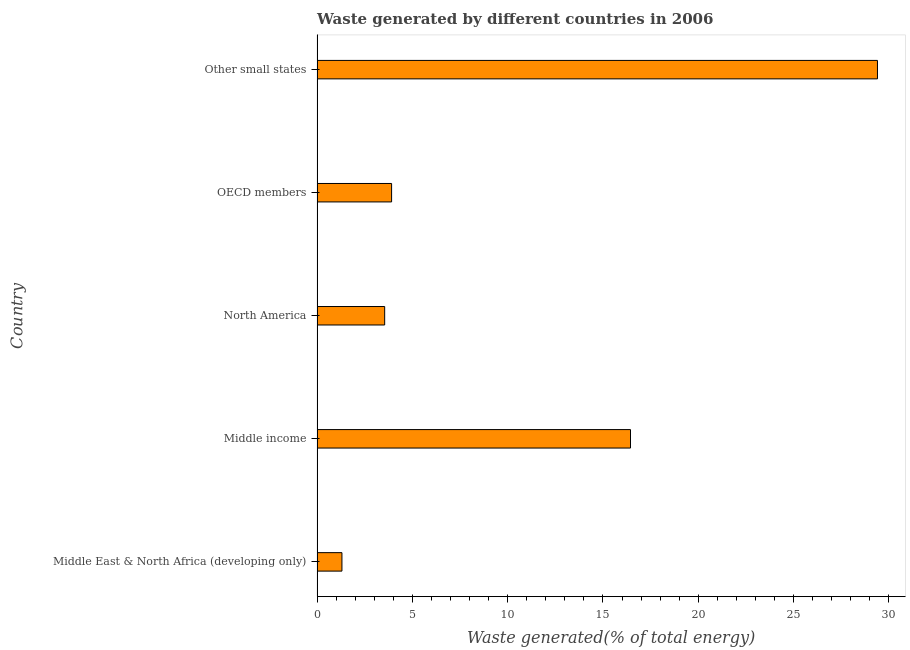What is the title of the graph?
Provide a short and direct response. Waste generated by different countries in 2006. What is the label or title of the X-axis?
Keep it short and to the point. Waste generated(% of total energy). What is the amount of waste generated in Middle income?
Your answer should be very brief. 16.44. Across all countries, what is the maximum amount of waste generated?
Your answer should be compact. 29.4. Across all countries, what is the minimum amount of waste generated?
Your answer should be compact. 1.31. In which country was the amount of waste generated maximum?
Make the answer very short. Other small states. In which country was the amount of waste generated minimum?
Give a very brief answer. Middle East & North Africa (developing only). What is the sum of the amount of waste generated?
Provide a short and direct response. 54.61. What is the difference between the amount of waste generated in Middle East & North Africa (developing only) and North America?
Provide a short and direct response. -2.24. What is the average amount of waste generated per country?
Your answer should be compact. 10.92. What is the median amount of waste generated?
Give a very brief answer. 3.91. What is the ratio of the amount of waste generated in Middle East & North Africa (developing only) to that in Other small states?
Give a very brief answer. 0.04. Is the difference between the amount of waste generated in Middle East & North Africa (developing only) and OECD members greater than the difference between any two countries?
Give a very brief answer. No. What is the difference between the highest and the second highest amount of waste generated?
Give a very brief answer. 12.96. Is the sum of the amount of waste generated in North America and Other small states greater than the maximum amount of waste generated across all countries?
Provide a succinct answer. Yes. What is the difference between the highest and the lowest amount of waste generated?
Offer a terse response. 28.1. How many bars are there?
Your answer should be compact. 5. What is the difference between two consecutive major ticks on the X-axis?
Provide a short and direct response. 5. Are the values on the major ticks of X-axis written in scientific E-notation?
Your response must be concise. No. What is the Waste generated(% of total energy) of Middle East & North Africa (developing only)?
Your response must be concise. 1.31. What is the Waste generated(% of total energy) of Middle income?
Give a very brief answer. 16.44. What is the Waste generated(% of total energy) of North America?
Keep it short and to the point. 3.55. What is the Waste generated(% of total energy) in OECD members?
Make the answer very short. 3.91. What is the Waste generated(% of total energy) in Other small states?
Your answer should be compact. 29.4. What is the difference between the Waste generated(% of total energy) in Middle East & North Africa (developing only) and Middle income?
Offer a terse response. -15.14. What is the difference between the Waste generated(% of total energy) in Middle East & North Africa (developing only) and North America?
Offer a very short reply. -2.24. What is the difference between the Waste generated(% of total energy) in Middle East & North Africa (developing only) and OECD members?
Make the answer very short. -2.61. What is the difference between the Waste generated(% of total energy) in Middle East & North Africa (developing only) and Other small states?
Make the answer very short. -28.1. What is the difference between the Waste generated(% of total energy) in Middle income and North America?
Give a very brief answer. 12.9. What is the difference between the Waste generated(% of total energy) in Middle income and OECD members?
Your answer should be very brief. 12.53. What is the difference between the Waste generated(% of total energy) in Middle income and Other small states?
Make the answer very short. -12.96. What is the difference between the Waste generated(% of total energy) in North America and OECD members?
Provide a succinct answer. -0.36. What is the difference between the Waste generated(% of total energy) in North America and Other small states?
Offer a very short reply. -25.85. What is the difference between the Waste generated(% of total energy) in OECD members and Other small states?
Keep it short and to the point. -25.49. What is the ratio of the Waste generated(% of total energy) in Middle East & North Africa (developing only) to that in Middle income?
Your response must be concise. 0.08. What is the ratio of the Waste generated(% of total energy) in Middle East & North Africa (developing only) to that in North America?
Offer a very short reply. 0.37. What is the ratio of the Waste generated(% of total energy) in Middle East & North Africa (developing only) to that in OECD members?
Offer a very short reply. 0.33. What is the ratio of the Waste generated(% of total energy) in Middle East & North Africa (developing only) to that in Other small states?
Provide a succinct answer. 0.04. What is the ratio of the Waste generated(% of total energy) in Middle income to that in North America?
Offer a terse response. 4.63. What is the ratio of the Waste generated(% of total energy) in Middle income to that in OECD members?
Make the answer very short. 4.21. What is the ratio of the Waste generated(% of total energy) in Middle income to that in Other small states?
Your answer should be very brief. 0.56. What is the ratio of the Waste generated(% of total energy) in North America to that in OECD members?
Provide a short and direct response. 0.91. What is the ratio of the Waste generated(% of total energy) in North America to that in Other small states?
Your response must be concise. 0.12. What is the ratio of the Waste generated(% of total energy) in OECD members to that in Other small states?
Your answer should be compact. 0.13. 